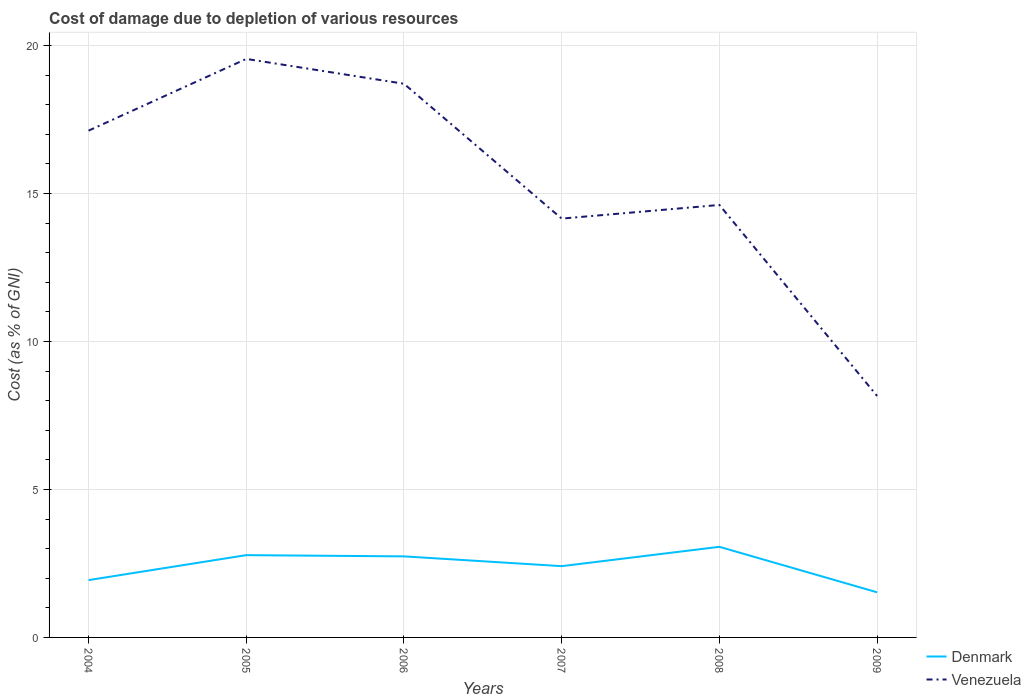Does the line corresponding to Denmark intersect with the line corresponding to Venezuela?
Your answer should be very brief. No. Across all years, what is the maximum cost of damage caused due to the depletion of various resources in Denmark?
Keep it short and to the point. 1.53. What is the total cost of damage caused due to the depletion of various resources in Venezuela in the graph?
Give a very brief answer. 4.1. What is the difference between the highest and the second highest cost of damage caused due to the depletion of various resources in Venezuela?
Your response must be concise. 11.39. How many lines are there?
Give a very brief answer. 2. How many years are there in the graph?
Provide a short and direct response. 6. Does the graph contain grids?
Your answer should be very brief. Yes. Where does the legend appear in the graph?
Your answer should be compact. Bottom right. How are the legend labels stacked?
Offer a very short reply. Vertical. What is the title of the graph?
Your answer should be very brief. Cost of damage due to depletion of various resources. What is the label or title of the X-axis?
Provide a succinct answer. Years. What is the label or title of the Y-axis?
Your answer should be very brief. Cost (as % of GNI). What is the Cost (as % of GNI) of Denmark in 2004?
Your response must be concise. 1.94. What is the Cost (as % of GNI) in Venezuela in 2004?
Your answer should be compact. 17.13. What is the Cost (as % of GNI) in Denmark in 2005?
Give a very brief answer. 2.78. What is the Cost (as % of GNI) of Venezuela in 2005?
Your answer should be very brief. 19.55. What is the Cost (as % of GNI) in Denmark in 2006?
Your response must be concise. 2.74. What is the Cost (as % of GNI) of Venezuela in 2006?
Make the answer very short. 18.71. What is the Cost (as % of GNI) in Denmark in 2007?
Provide a succinct answer. 2.41. What is the Cost (as % of GNI) in Venezuela in 2007?
Ensure brevity in your answer.  14.15. What is the Cost (as % of GNI) of Denmark in 2008?
Offer a terse response. 3.06. What is the Cost (as % of GNI) in Venezuela in 2008?
Your response must be concise. 14.62. What is the Cost (as % of GNI) in Denmark in 2009?
Your answer should be compact. 1.53. What is the Cost (as % of GNI) in Venezuela in 2009?
Make the answer very short. 8.16. Across all years, what is the maximum Cost (as % of GNI) of Denmark?
Give a very brief answer. 3.06. Across all years, what is the maximum Cost (as % of GNI) in Venezuela?
Keep it short and to the point. 19.55. Across all years, what is the minimum Cost (as % of GNI) of Denmark?
Your answer should be compact. 1.53. Across all years, what is the minimum Cost (as % of GNI) in Venezuela?
Your answer should be very brief. 8.16. What is the total Cost (as % of GNI) of Denmark in the graph?
Provide a succinct answer. 14.45. What is the total Cost (as % of GNI) of Venezuela in the graph?
Offer a very short reply. 92.32. What is the difference between the Cost (as % of GNI) in Denmark in 2004 and that in 2005?
Offer a very short reply. -0.84. What is the difference between the Cost (as % of GNI) in Venezuela in 2004 and that in 2005?
Your answer should be very brief. -2.42. What is the difference between the Cost (as % of GNI) of Denmark in 2004 and that in 2006?
Provide a short and direct response. -0.8. What is the difference between the Cost (as % of GNI) of Venezuela in 2004 and that in 2006?
Provide a succinct answer. -1.59. What is the difference between the Cost (as % of GNI) of Denmark in 2004 and that in 2007?
Your answer should be compact. -0.47. What is the difference between the Cost (as % of GNI) of Venezuela in 2004 and that in 2007?
Provide a succinct answer. 2.97. What is the difference between the Cost (as % of GNI) of Denmark in 2004 and that in 2008?
Provide a succinct answer. -1.12. What is the difference between the Cost (as % of GNI) in Venezuela in 2004 and that in 2008?
Your response must be concise. 2.51. What is the difference between the Cost (as % of GNI) of Denmark in 2004 and that in 2009?
Make the answer very short. 0.41. What is the difference between the Cost (as % of GNI) of Venezuela in 2004 and that in 2009?
Your answer should be compact. 8.97. What is the difference between the Cost (as % of GNI) in Denmark in 2005 and that in 2006?
Ensure brevity in your answer.  0.04. What is the difference between the Cost (as % of GNI) of Venezuela in 2005 and that in 2006?
Provide a short and direct response. 0.84. What is the difference between the Cost (as % of GNI) in Denmark in 2005 and that in 2007?
Keep it short and to the point. 0.37. What is the difference between the Cost (as % of GNI) in Venezuela in 2005 and that in 2007?
Make the answer very short. 5.4. What is the difference between the Cost (as % of GNI) in Denmark in 2005 and that in 2008?
Keep it short and to the point. -0.28. What is the difference between the Cost (as % of GNI) in Venezuela in 2005 and that in 2008?
Provide a succinct answer. 4.94. What is the difference between the Cost (as % of GNI) in Denmark in 2005 and that in 2009?
Give a very brief answer. 1.26. What is the difference between the Cost (as % of GNI) of Venezuela in 2005 and that in 2009?
Offer a very short reply. 11.39. What is the difference between the Cost (as % of GNI) in Denmark in 2006 and that in 2007?
Your answer should be very brief. 0.33. What is the difference between the Cost (as % of GNI) of Venezuela in 2006 and that in 2007?
Ensure brevity in your answer.  4.56. What is the difference between the Cost (as % of GNI) of Denmark in 2006 and that in 2008?
Provide a short and direct response. -0.32. What is the difference between the Cost (as % of GNI) in Venezuela in 2006 and that in 2008?
Provide a short and direct response. 4.1. What is the difference between the Cost (as % of GNI) in Denmark in 2006 and that in 2009?
Provide a short and direct response. 1.21. What is the difference between the Cost (as % of GNI) in Venezuela in 2006 and that in 2009?
Provide a succinct answer. 10.55. What is the difference between the Cost (as % of GNI) in Denmark in 2007 and that in 2008?
Ensure brevity in your answer.  -0.65. What is the difference between the Cost (as % of GNI) of Venezuela in 2007 and that in 2008?
Provide a succinct answer. -0.46. What is the difference between the Cost (as % of GNI) of Denmark in 2007 and that in 2009?
Keep it short and to the point. 0.88. What is the difference between the Cost (as % of GNI) in Venezuela in 2007 and that in 2009?
Give a very brief answer. 5.99. What is the difference between the Cost (as % of GNI) in Denmark in 2008 and that in 2009?
Give a very brief answer. 1.54. What is the difference between the Cost (as % of GNI) in Venezuela in 2008 and that in 2009?
Your answer should be very brief. 6.45. What is the difference between the Cost (as % of GNI) in Denmark in 2004 and the Cost (as % of GNI) in Venezuela in 2005?
Your answer should be compact. -17.61. What is the difference between the Cost (as % of GNI) of Denmark in 2004 and the Cost (as % of GNI) of Venezuela in 2006?
Your answer should be compact. -16.77. What is the difference between the Cost (as % of GNI) of Denmark in 2004 and the Cost (as % of GNI) of Venezuela in 2007?
Offer a very short reply. -12.22. What is the difference between the Cost (as % of GNI) in Denmark in 2004 and the Cost (as % of GNI) in Venezuela in 2008?
Offer a terse response. -12.68. What is the difference between the Cost (as % of GNI) in Denmark in 2004 and the Cost (as % of GNI) in Venezuela in 2009?
Provide a succinct answer. -6.22. What is the difference between the Cost (as % of GNI) in Denmark in 2005 and the Cost (as % of GNI) in Venezuela in 2006?
Give a very brief answer. -15.93. What is the difference between the Cost (as % of GNI) of Denmark in 2005 and the Cost (as % of GNI) of Venezuela in 2007?
Your answer should be compact. -11.37. What is the difference between the Cost (as % of GNI) in Denmark in 2005 and the Cost (as % of GNI) in Venezuela in 2008?
Your answer should be compact. -11.83. What is the difference between the Cost (as % of GNI) of Denmark in 2005 and the Cost (as % of GNI) of Venezuela in 2009?
Offer a very short reply. -5.38. What is the difference between the Cost (as % of GNI) in Denmark in 2006 and the Cost (as % of GNI) in Venezuela in 2007?
Provide a succinct answer. -11.42. What is the difference between the Cost (as % of GNI) of Denmark in 2006 and the Cost (as % of GNI) of Venezuela in 2008?
Keep it short and to the point. -11.88. What is the difference between the Cost (as % of GNI) of Denmark in 2006 and the Cost (as % of GNI) of Venezuela in 2009?
Give a very brief answer. -5.42. What is the difference between the Cost (as % of GNI) in Denmark in 2007 and the Cost (as % of GNI) in Venezuela in 2008?
Provide a short and direct response. -12.21. What is the difference between the Cost (as % of GNI) of Denmark in 2007 and the Cost (as % of GNI) of Venezuela in 2009?
Give a very brief answer. -5.75. What is the difference between the Cost (as % of GNI) in Denmark in 2008 and the Cost (as % of GNI) in Venezuela in 2009?
Your answer should be very brief. -5.1. What is the average Cost (as % of GNI) in Denmark per year?
Offer a very short reply. 2.41. What is the average Cost (as % of GNI) of Venezuela per year?
Make the answer very short. 15.39. In the year 2004, what is the difference between the Cost (as % of GNI) in Denmark and Cost (as % of GNI) in Venezuela?
Provide a short and direct response. -15.19. In the year 2005, what is the difference between the Cost (as % of GNI) of Denmark and Cost (as % of GNI) of Venezuela?
Offer a very short reply. -16.77. In the year 2006, what is the difference between the Cost (as % of GNI) of Denmark and Cost (as % of GNI) of Venezuela?
Offer a terse response. -15.97. In the year 2007, what is the difference between the Cost (as % of GNI) in Denmark and Cost (as % of GNI) in Venezuela?
Offer a terse response. -11.75. In the year 2008, what is the difference between the Cost (as % of GNI) of Denmark and Cost (as % of GNI) of Venezuela?
Provide a succinct answer. -11.55. In the year 2009, what is the difference between the Cost (as % of GNI) in Denmark and Cost (as % of GNI) in Venezuela?
Give a very brief answer. -6.64. What is the ratio of the Cost (as % of GNI) in Denmark in 2004 to that in 2005?
Keep it short and to the point. 0.7. What is the ratio of the Cost (as % of GNI) of Venezuela in 2004 to that in 2005?
Make the answer very short. 0.88. What is the ratio of the Cost (as % of GNI) of Denmark in 2004 to that in 2006?
Provide a succinct answer. 0.71. What is the ratio of the Cost (as % of GNI) of Venezuela in 2004 to that in 2006?
Offer a terse response. 0.92. What is the ratio of the Cost (as % of GNI) of Denmark in 2004 to that in 2007?
Provide a succinct answer. 0.8. What is the ratio of the Cost (as % of GNI) in Venezuela in 2004 to that in 2007?
Keep it short and to the point. 1.21. What is the ratio of the Cost (as % of GNI) in Denmark in 2004 to that in 2008?
Your response must be concise. 0.63. What is the ratio of the Cost (as % of GNI) in Venezuela in 2004 to that in 2008?
Make the answer very short. 1.17. What is the ratio of the Cost (as % of GNI) in Denmark in 2004 to that in 2009?
Your answer should be compact. 1.27. What is the ratio of the Cost (as % of GNI) in Venezuela in 2004 to that in 2009?
Your answer should be very brief. 2.1. What is the ratio of the Cost (as % of GNI) of Denmark in 2005 to that in 2006?
Ensure brevity in your answer.  1.02. What is the ratio of the Cost (as % of GNI) in Venezuela in 2005 to that in 2006?
Your answer should be very brief. 1.04. What is the ratio of the Cost (as % of GNI) of Denmark in 2005 to that in 2007?
Ensure brevity in your answer.  1.15. What is the ratio of the Cost (as % of GNI) of Venezuela in 2005 to that in 2007?
Offer a terse response. 1.38. What is the ratio of the Cost (as % of GNI) of Denmark in 2005 to that in 2008?
Provide a short and direct response. 0.91. What is the ratio of the Cost (as % of GNI) of Venezuela in 2005 to that in 2008?
Ensure brevity in your answer.  1.34. What is the ratio of the Cost (as % of GNI) in Denmark in 2005 to that in 2009?
Your answer should be very brief. 1.82. What is the ratio of the Cost (as % of GNI) in Venezuela in 2005 to that in 2009?
Your answer should be compact. 2.4. What is the ratio of the Cost (as % of GNI) of Denmark in 2006 to that in 2007?
Make the answer very short. 1.14. What is the ratio of the Cost (as % of GNI) in Venezuela in 2006 to that in 2007?
Offer a very short reply. 1.32. What is the ratio of the Cost (as % of GNI) of Denmark in 2006 to that in 2008?
Offer a very short reply. 0.89. What is the ratio of the Cost (as % of GNI) in Venezuela in 2006 to that in 2008?
Make the answer very short. 1.28. What is the ratio of the Cost (as % of GNI) of Denmark in 2006 to that in 2009?
Keep it short and to the point. 1.8. What is the ratio of the Cost (as % of GNI) of Venezuela in 2006 to that in 2009?
Offer a terse response. 2.29. What is the ratio of the Cost (as % of GNI) of Denmark in 2007 to that in 2008?
Keep it short and to the point. 0.79. What is the ratio of the Cost (as % of GNI) in Venezuela in 2007 to that in 2008?
Offer a very short reply. 0.97. What is the ratio of the Cost (as % of GNI) of Denmark in 2007 to that in 2009?
Ensure brevity in your answer.  1.58. What is the ratio of the Cost (as % of GNI) in Venezuela in 2007 to that in 2009?
Keep it short and to the point. 1.73. What is the ratio of the Cost (as % of GNI) of Denmark in 2008 to that in 2009?
Ensure brevity in your answer.  2.01. What is the ratio of the Cost (as % of GNI) of Venezuela in 2008 to that in 2009?
Provide a short and direct response. 1.79. What is the difference between the highest and the second highest Cost (as % of GNI) in Denmark?
Make the answer very short. 0.28. What is the difference between the highest and the second highest Cost (as % of GNI) in Venezuela?
Give a very brief answer. 0.84. What is the difference between the highest and the lowest Cost (as % of GNI) of Denmark?
Ensure brevity in your answer.  1.54. What is the difference between the highest and the lowest Cost (as % of GNI) in Venezuela?
Your answer should be compact. 11.39. 